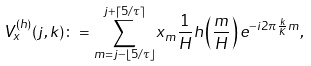<formula> <loc_0><loc_0><loc_500><loc_500>V ^ { ( h ) } _ { x } ( j , k ) \colon = \sum ^ { j + \lceil 5 / \tau \rceil } _ { m = j - \lfloor 5 / \tau \rfloor } x _ { m } \frac { 1 } { H } h \left ( \frac { m } { H } \right ) e ^ { - i 2 \pi \frac { k } { K } m } ,</formula> 